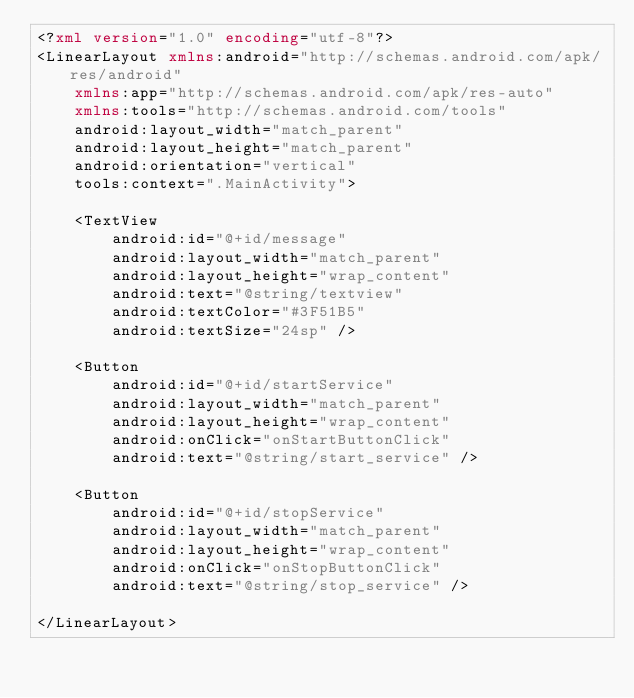Convert code to text. <code><loc_0><loc_0><loc_500><loc_500><_XML_><?xml version="1.0" encoding="utf-8"?>
<LinearLayout xmlns:android="http://schemas.android.com/apk/res/android"
    xmlns:app="http://schemas.android.com/apk/res-auto"
    xmlns:tools="http://schemas.android.com/tools"
    android:layout_width="match_parent"
    android:layout_height="match_parent"
    android:orientation="vertical"
    tools:context=".MainActivity">

    <TextView
        android:id="@+id/message"
        android:layout_width="match_parent"
        android:layout_height="wrap_content"
        android:text="@string/textview"
        android:textColor="#3F51B5"
        android:textSize="24sp" />

    <Button
        android:id="@+id/startService"
        android:layout_width="match_parent"
        android:layout_height="wrap_content"
        android:onClick="onStartButtonClick"
        android:text="@string/start_service" />

    <Button
        android:id="@+id/stopService"
        android:layout_width="match_parent"
        android:layout_height="wrap_content"
        android:onClick="onStopButtonClick"
        android:text="@string/stop_service" />

</LinearLayout></code> 